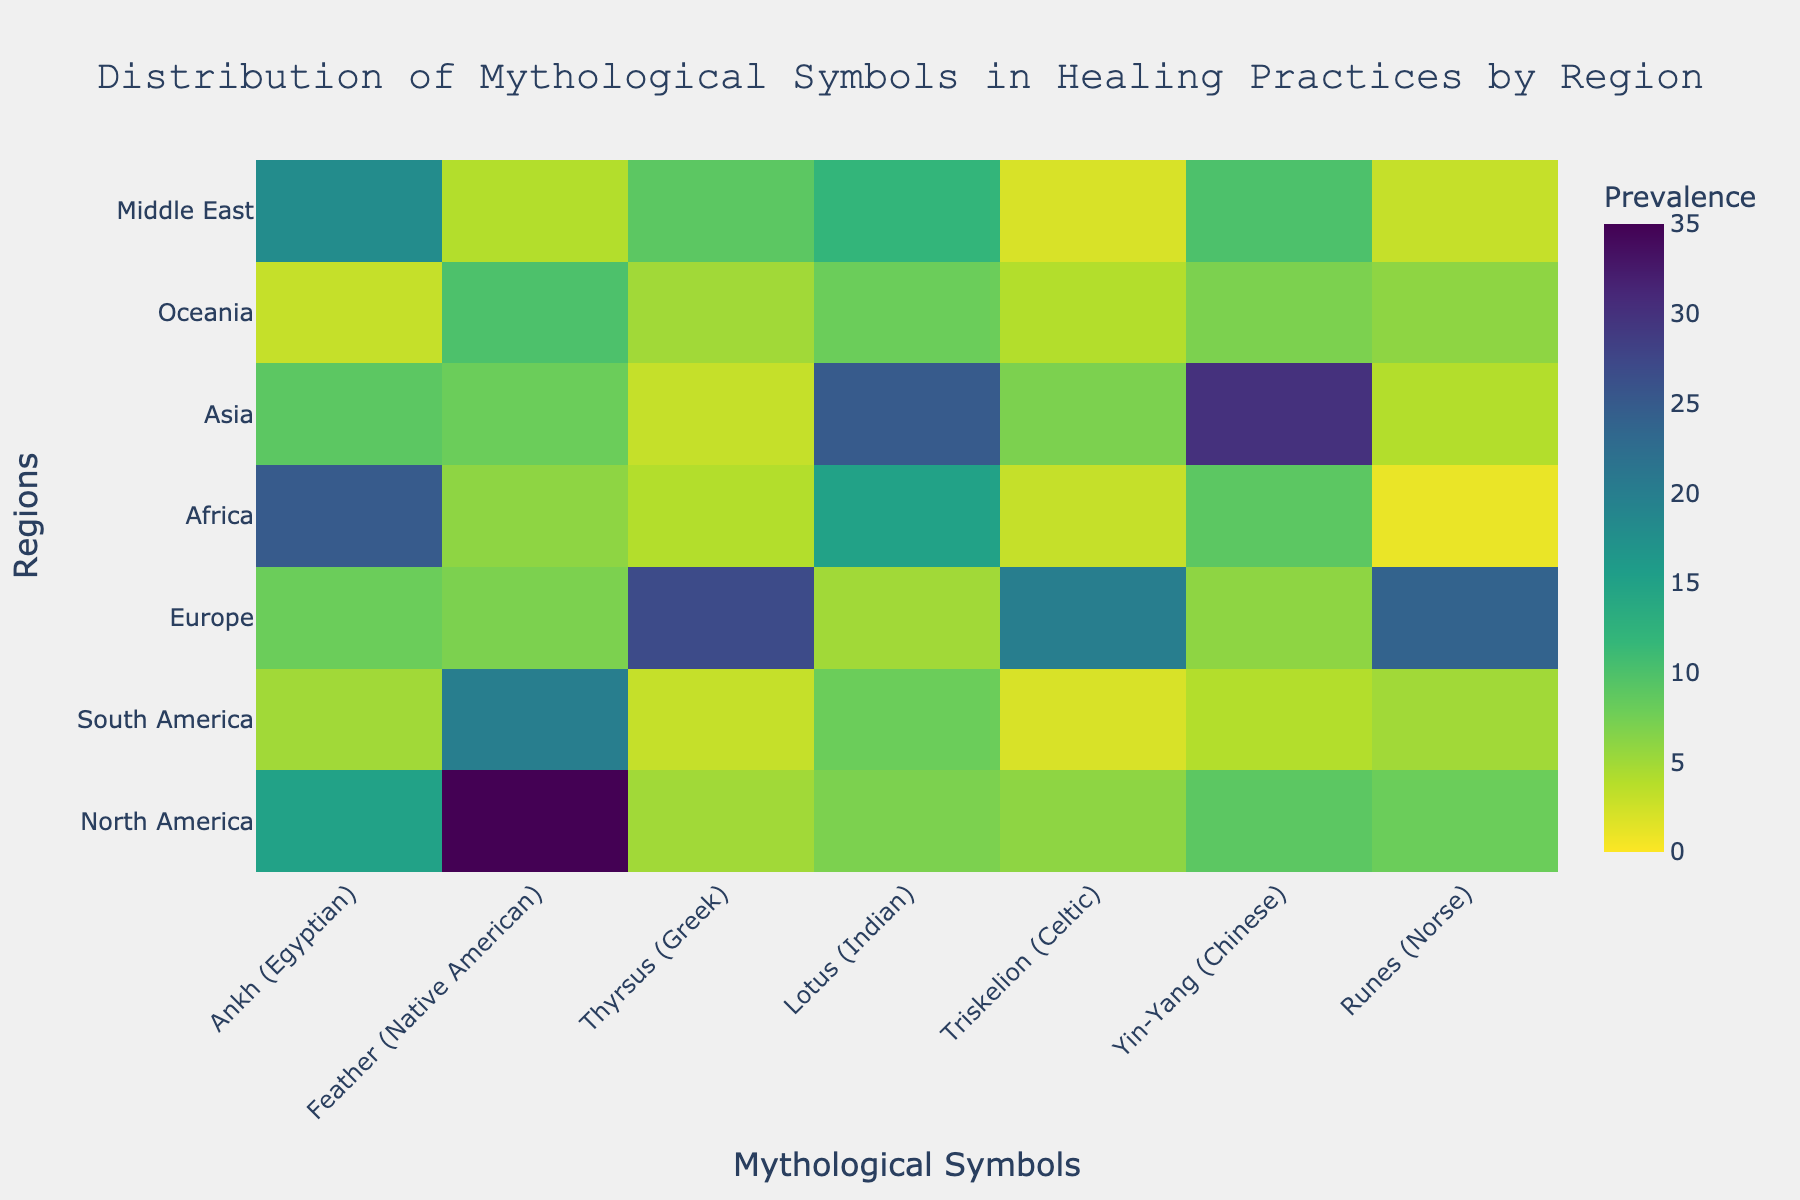Which region shows the highest prevalence of the 'Ankh' symbol? Look at the 'Ankh' column and find the region with the highest value. Africa has the highest prevalence with a value of 25.
Answer: Africa What is the title of the heatmap? The title is usually displayed at the top of the figure. The title of the heatmap is 'Distribution of Mythological Symbols in Healing Practices by Region'.
Answer: Distribution of Mythological Symbols in Healing Practices by Region Which mythological symbol has the highest overall prevalence in Asia? Refer to the row for 'Asia' and identify the highest value. The highest value in this row is 30 for the 'Yin-Yang' symbol.
Answer: Yin-Yang How many regions have a prevalence value greater than 20 for any symbol? Check each region for any symbol value greater than 20. North America (1), Europe (2), and Asia (1) have such values. Thus, there are three regions.
Answer: 3 What's the difference in prevalence of the 'Feather' symbol between North America and South America? Subtract the prevalence in South America from that in North America for the 'Feather' symbol. The difference is 35 - 20 = 15.
Answer: 15 Which region has the least prevalence for the 'Runes' symbol? Find the smallest value in the 'Runes' column. Africa has the least prevalence with a value of 1.
Answer: Africa Compare the prevalence of the 'Thyrsus' symbol in Europe and the Middle East. Which region has more? Find the values for the 'Thyrsus' symbol in Europe (27) and the Middle East (9). Europe has more prevalence.
Answer: Europe What is the average prevalence of the 'Lotus' symbol across all regions? Sum all the prevalence values for the 'Lotus' symbol and divide by the number of regions (7). The sum is 7 + 8 + 5 + 15 + 25 + 8 + 12 = 80, so the average is 80 / 7 ≈ 11.43.
Answer: 11.43 Which region shows the highest variance in the prevalence of different symbols? Calculate the variance for each region and compare. With visual inspection, Europe shows high variance with the 'Thyrsus' (27) and 'Triskelion' (20) being much higher than others.
Answer: Europe What is the sum of the prevalence values for the 'Yin-Yang' symbol across all regions? Add all the values in the 'Yin-Yang' column: 9 + 4 + 6 + 9 + 30 + 7 + 10 = 75.
Answer: 75 